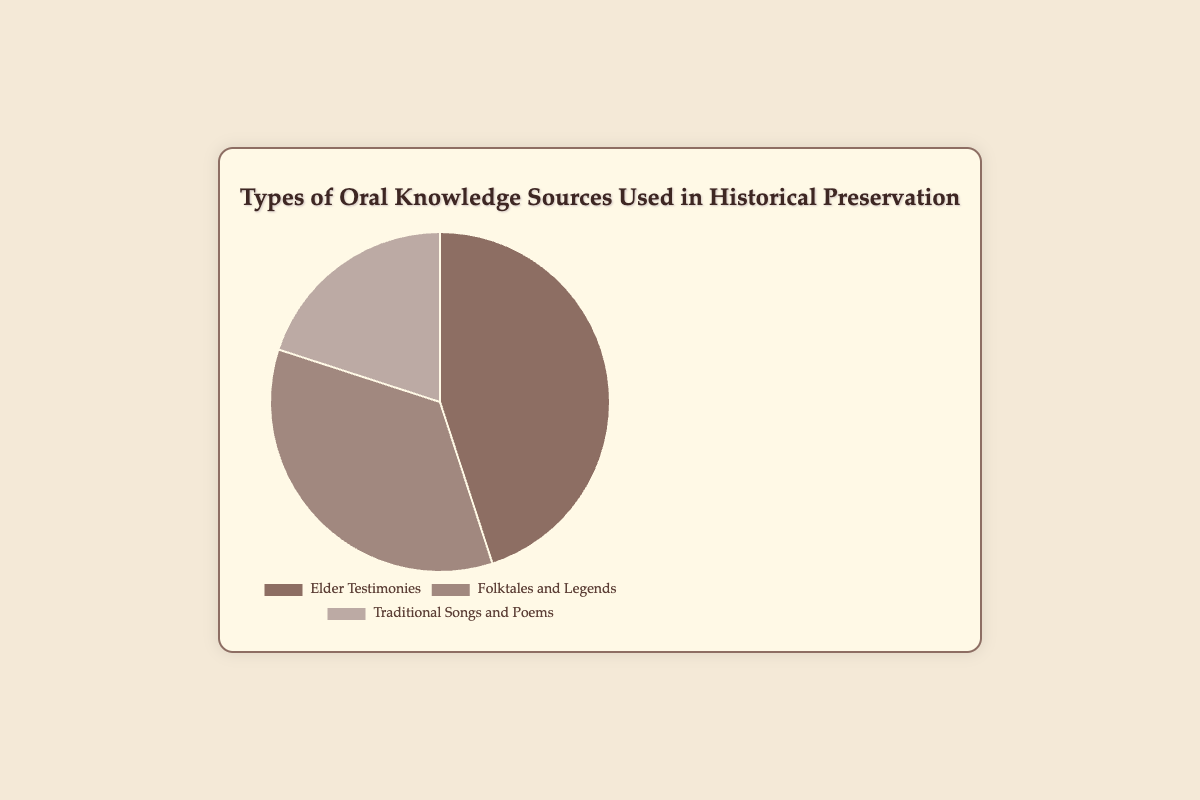What type of oral knowledge source is used the most in historical preservation? By looking at the pie chart, the largest segment represents "Elder Testimonies". Therefore, Elder Testimonies is used the most.
Answer: Elder Testimonies Which segment represents 35% of the total sources used for historical preservation? Referring to the segments, "Folktales and Legends" represents 35% of the pie chart.
Answer: Folktales and Legends What is the combined percentage of Elder Testimonies and Traditional Songs and Poems? The percentage for Elder Testimonies is 45% and for Traditional Songs and Poems is 20%. By summing these up: 45% + 20% = 65%.
Answer: 65% Which source of oral knowledge has the smallest representation in the pie chart? The smallest segment, visually, is "Traditional Songs and Poems", which is represented by 20%.
Answer: Traditional Songs and Poems How much larger is the percentage of Elder Testimonies compared to Traditional Songs and Poems? Elder Testimonies is 45% and Traditional Songs and Poems is 20%. To find how much larger, calculate 45% - 20% = 25%.
Answer: 25% What is the difference in percentage between Folktales and Legends and Traditional Songs and Poems? Folktales and Legends is 35% and Traditional Songs and Poems is 20%. The difference is 35% - 20% = 15%.
Answer: 15% What proportion of the total is represented by Elder Testimonies and Folktales and Legends together? Elder Testimonies is 45% and Folktales and Legends is 35%. Adding these together: 45% + 35% = 80%.
Answer: 80% If Traditional Songs and Poems took up 10% more of the pie chart, what would its new percentage be? Traditional Songs and Poems currently is 20%. Adding 10% more would result in 20% + 10% = 30%.
Answer: 30% Arrange the sources of oral knowledge from highest to lowest based on their percentages. By inspecting the pie chart, Elder Testimonies is 45%, Folktales and Legends is 35%, and Traditional Songs and Poems is 20%. Arranging them: Elder Testimonies, Folktales and Legends, Traditional Songs and Poems.
Answer: Elder Testimonies, Folktales and Legends, Traditional Songs and Poems 